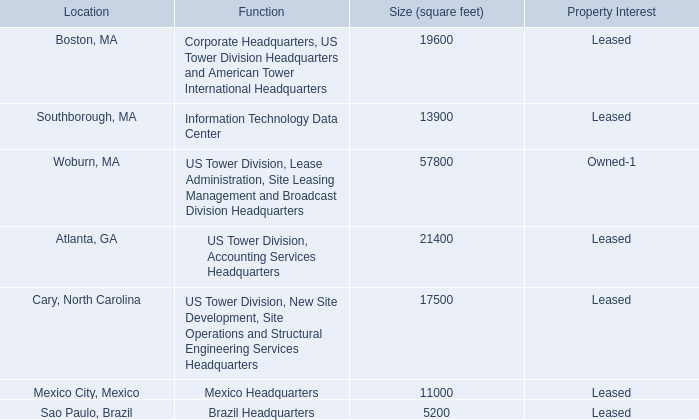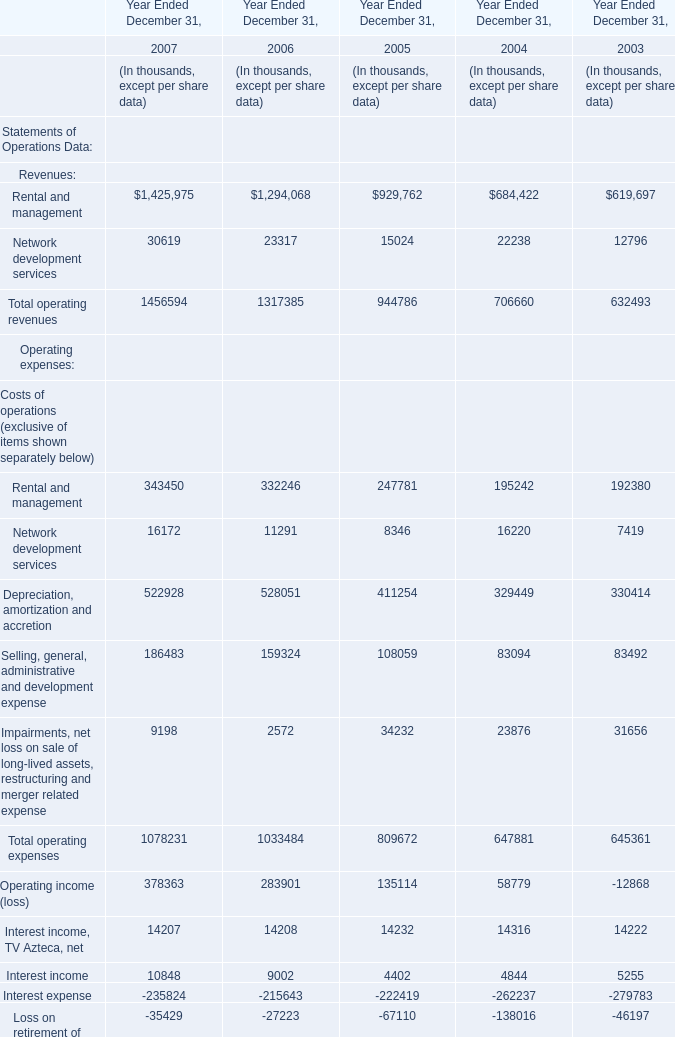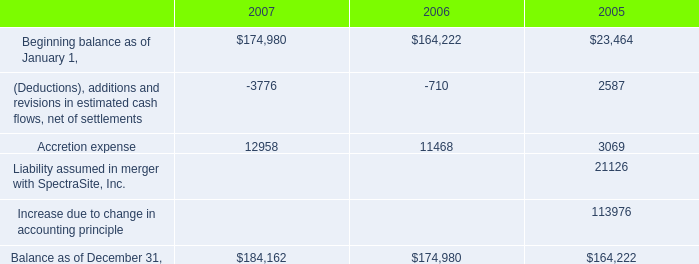What's the sum of the Selling, general, administrative and development expense in the years where Income tax (provision) benefit is positive? (in thousand) 
Computations: (83094 + 83492)
Answer: 166586.0. 